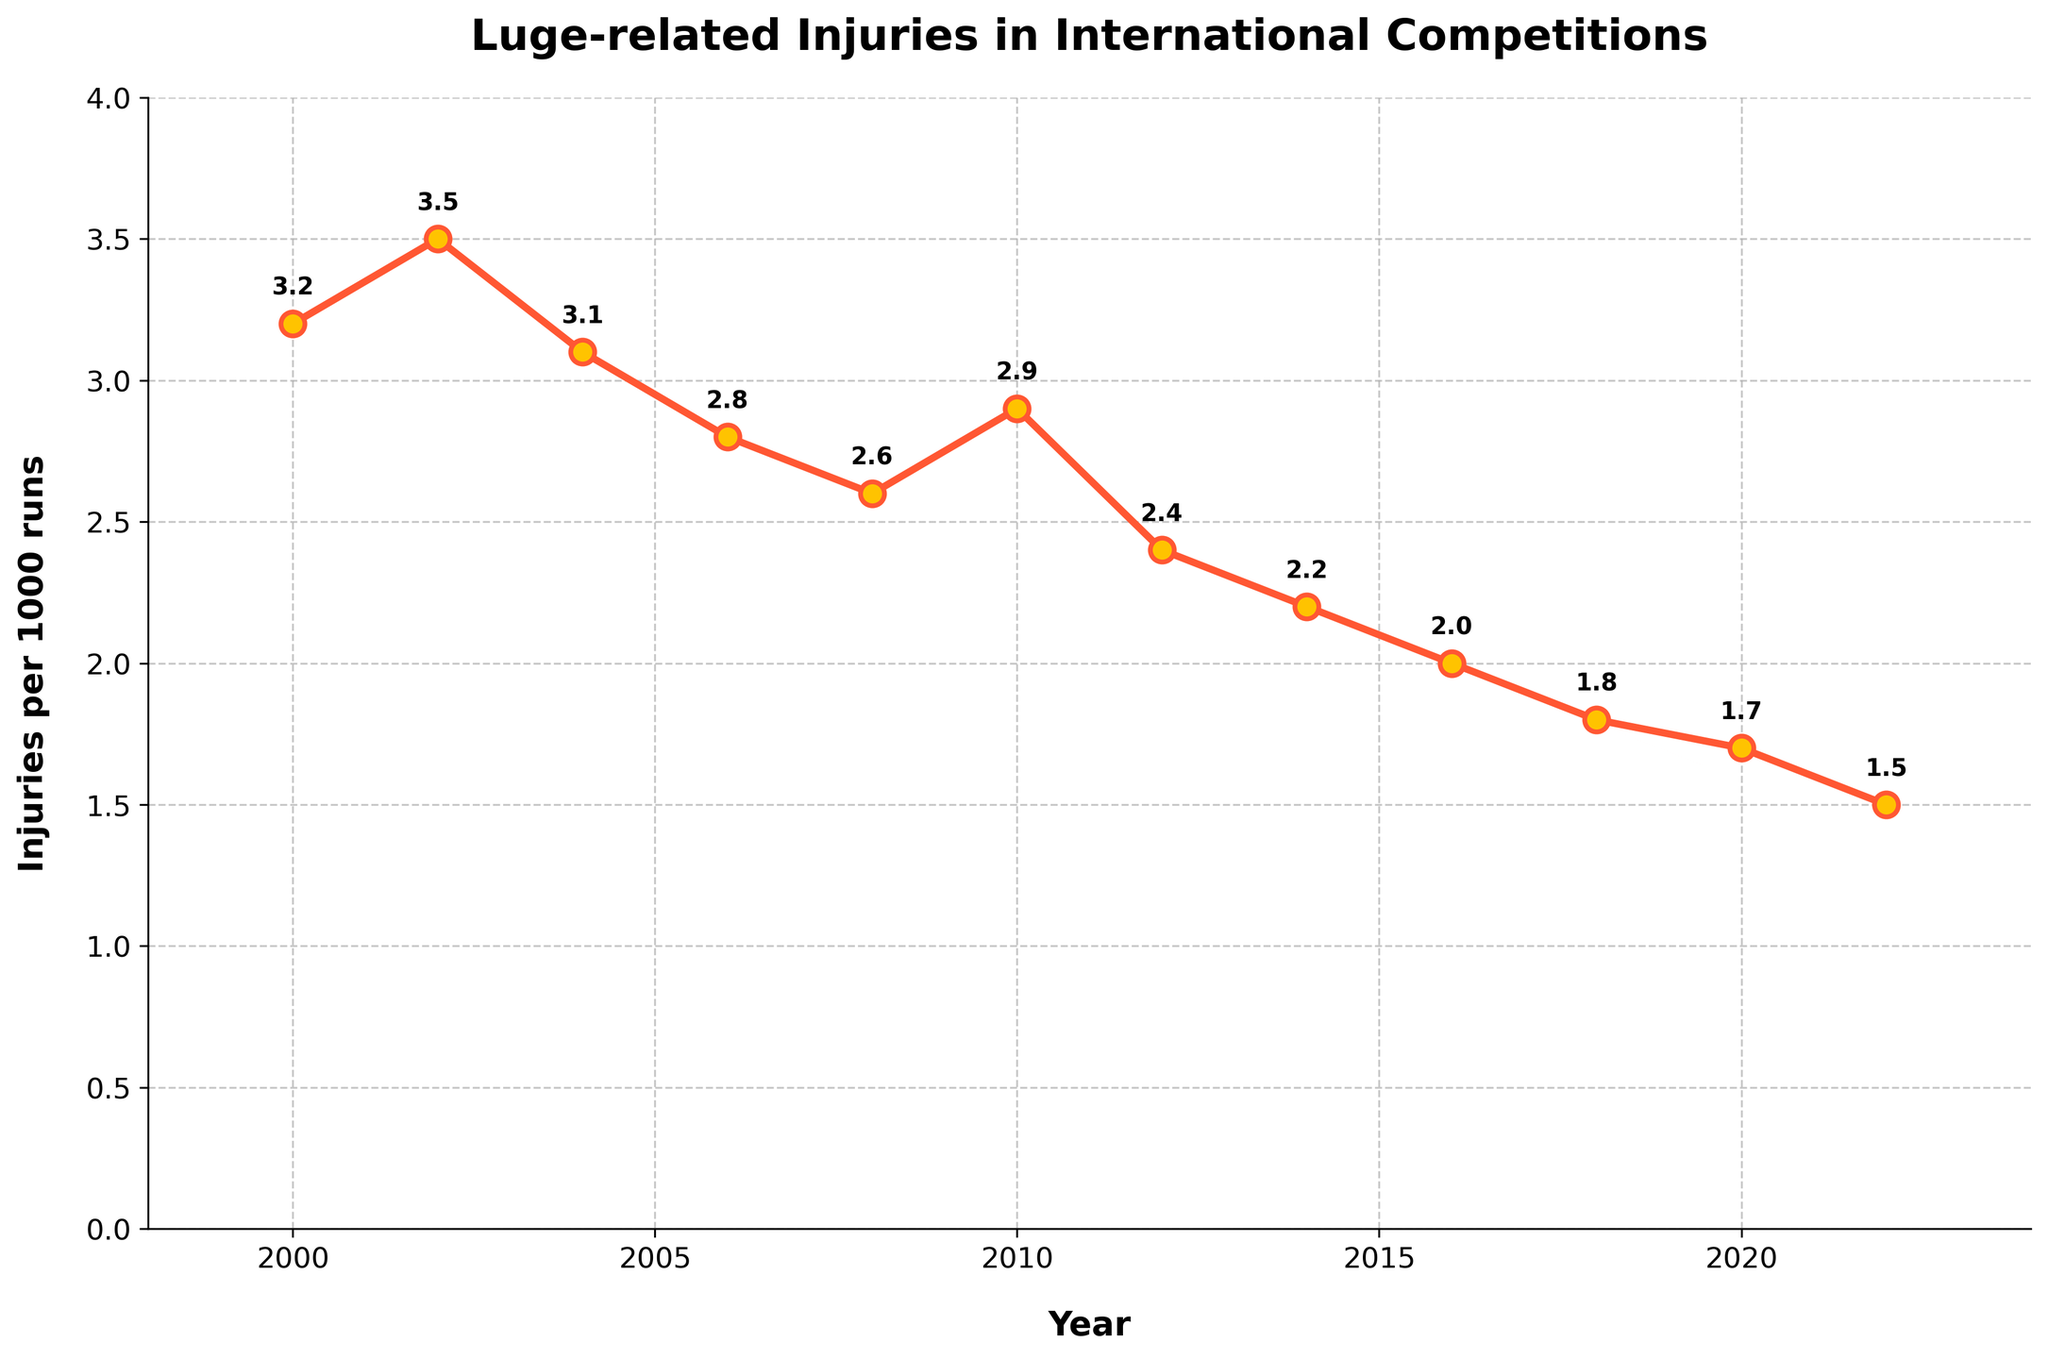What is the general trend of luge-related injuries between 2000 and 2022? To find the general trend, observe the direction of the line over the entire period. The line consistently slopes downward from 2000 to 2022, indicating a decrease in injuries.
Answer: Decreasing trend Which year experienced the highest number of injuries per 1000 runs? Look for the highest point on the chart. The peak value of 3.5 appears at the year 2002.
Answer: 2002 How many years had an injury rate of 2.0 or lower? Identify the years when the injury rate is below or equal to 2.0 by examining each corresponding data point: 2016 (2.0), 2018 (1.8), 2020 (1.7), 2022 (1.5). There are four such years.
Answer: 4 By how much did the number of injuries per 1000 runs decrease from 2002 to 2018? Subtract the injuries in 2018 (1.8) from the injuries in 2002 (3.5): 3.5 - 1.8 = 1.7.
Answer: 1.7 Which two consecutive years showed the largest drop in injury rates? Compare the differences between consecutive years and identify the largest drop: 2002-2004 (0.4), 2004-2006 (0.3), 2006-2008 (0.2), 2008-2010 (-0.3), 2010-2012 (0.5), 2012-2014 (0.2), 2014-2016 (0.2), 2016-2018 (0.2), 2018-2020 (0.1), 2020-2022 (0.2). The largest drop is from 2010 to 2012 (0.5).
Answer: 2010-2012 During which time period did injuries decrease steadily over four consecutive data points? Look for a sequence of four consecutive data points with a consistent decrease: 2006 to 2014 (2.8, 2.6, 2.4, 2.2) shows a steady decrease.
Answer: 2006-2014 By what percentage did the injury rate decrease from 2000 to 2022? Calculate the percentage decrease: ((3.2 - 1.5) / 3.2) * 100 = 53.13%.
Answer: 53.13% How does the number of injuries in 2014 compare to 2020? Compare the values directly: 2.2 in 2014 and 1.7 in 2020, the rate in 2020 is lower.
Answer: Lower in 2020 What is the average number of injuries per 1000 runs across all the years shown? Find the sum of the injury rates and divide by the number of years: (3.2 + 3.5 + 3.1 + 2.8 + 2.6 + 2.9 + 2.4 + 2.2 + 2.0 + 1.8 + 1.7 + 1.5) / 12 = 2.53.
Answer: 2.53 What is the difference in the number of injuries per 1000 runs between 2004 and 2008? Subtract the injuries in 2008 (2.6) from the injuries in 2004 (3.1): 3.1 - 2.6 = 0.5.
Answer: 0.5 